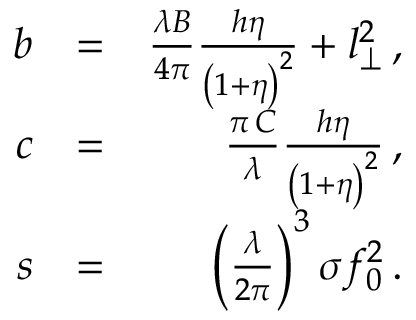<formula> <loc_0><loc_0><loc_500><loc_500>\begin{array} { r l r } { b } & { = } & { \frac { \lambda B } { 4 \pi } \frac { h \eta } { \left ( 1 + \eta \right ) ^ { 2 } } + l _ { \perp } ^ { 2 } \, , } \\ { c } & { = } & { \frac { \pi \, C } { \lambda } \frac { h \eta } { \left ( 1 + \eta \right ) ^ { 2 } } \, , } \\ { s } & { = } & { \left ( \frac { \lambda } { 2 \pi } \right ) ^ { 3 } \sigma f _ { 0 } ^ { 2 } \, . } \end{array}</formula> 